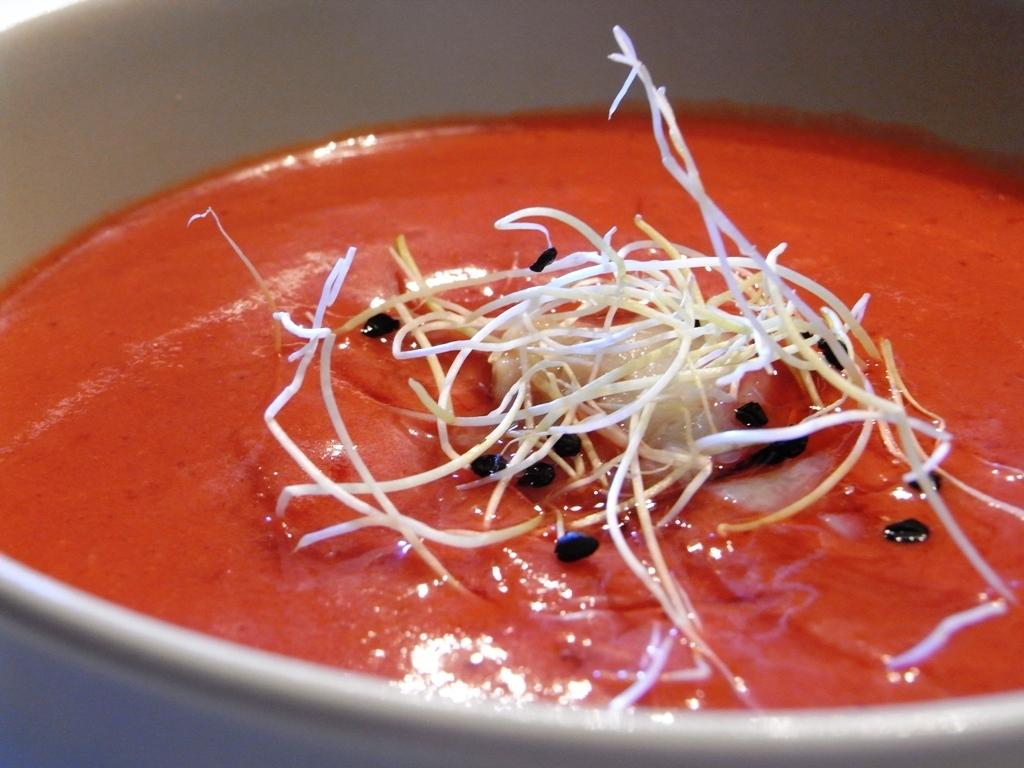What is present in the image? There is a bowl in the image. What is inside the bowl? There is food in the bowl. What type of pocket can be seen in the image? There is no pocket present in the image. What place is depicted in the image? The image does not depict a specific place; it only shows a bowl with food in it. 